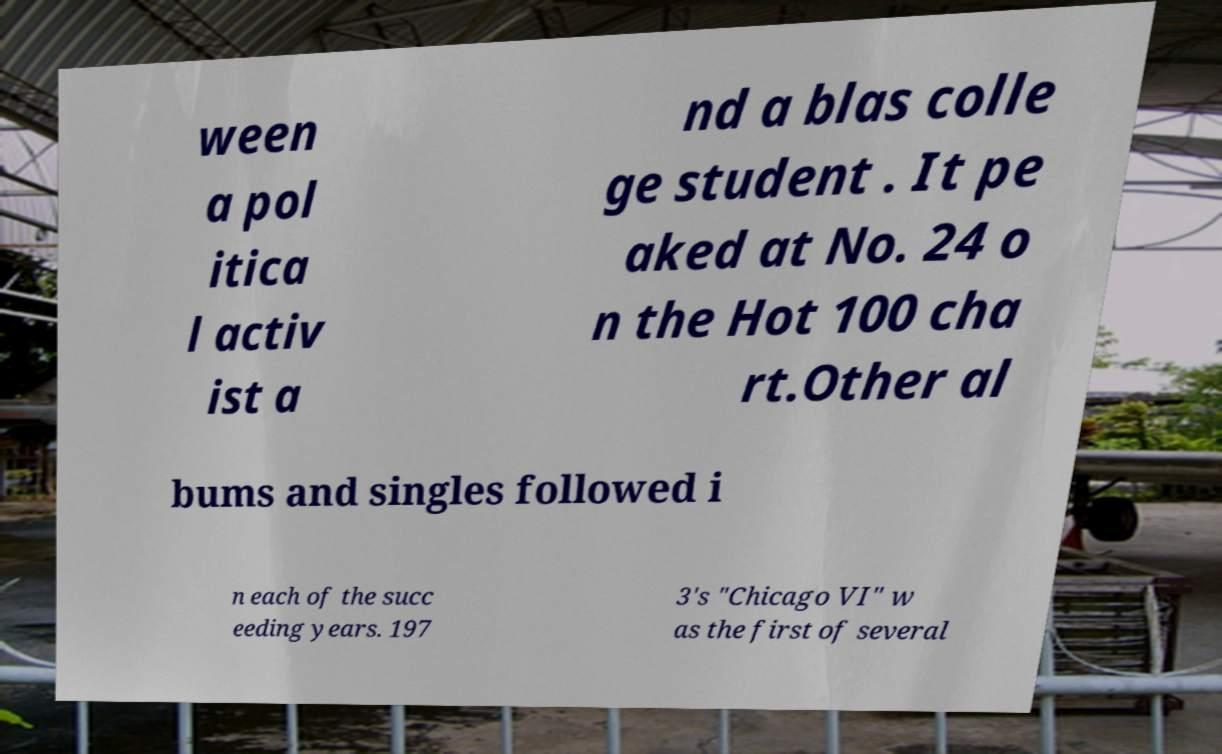Please identify and transcribe the text found in this image. ween a pol itica l activ ist a nd a blas colle ge student . It pe aked at No. 24 o n the Hot 100 cha rt.Other al bums and singles followed i n each of the succ eeding years. 197 3's "Chicago VI" w as the first of several 